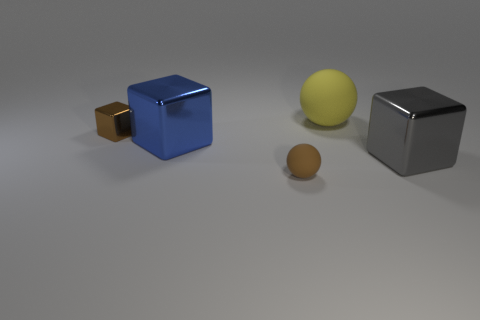Does the small shiny object have the same color as the big metallic cube right of the blue metallic block? no 